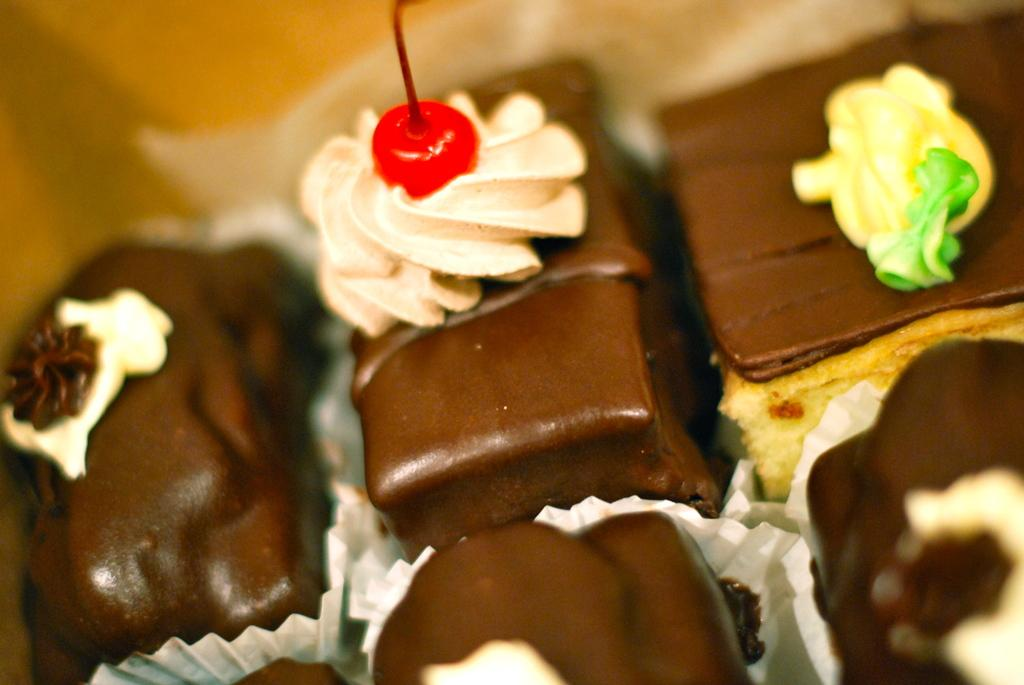What type of food is present in the image? There are cake pieces in the image. What colors can be seen on the cake pieces? The cake pieces have various colors: brown, cream, yellow, green, and red. How are the cake pieces being served? The cake pieces are in paper bowls. What color are the paper bowls? The paper bowls are white in color. Can you describe the background of the image? The background of the image is blurry. What type of fruit is being shared between partners in the image? There is no fruit or partners present in the image; it features cake pieces in paper bowls. 